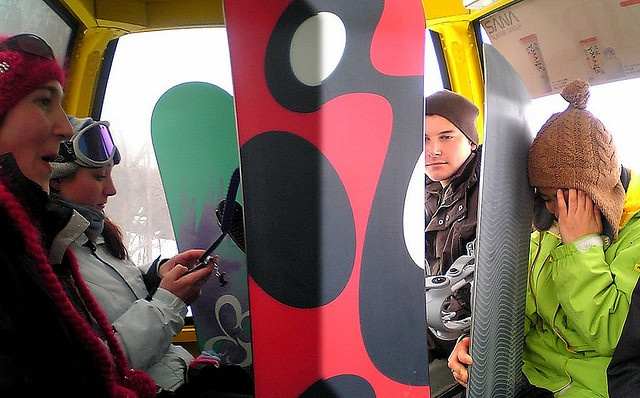Describe the objects in this image and their specific colors. I can see snowboard in darkgray, gray, black, brown, and salmon tones, people in darkgray, black, maroon, and gray tones, people in darkgray, olive, and brown tones, people in darkgray, gray, black, and maroon tones, and snowboard in darkgray, teal, black, and gray tones in this image. 